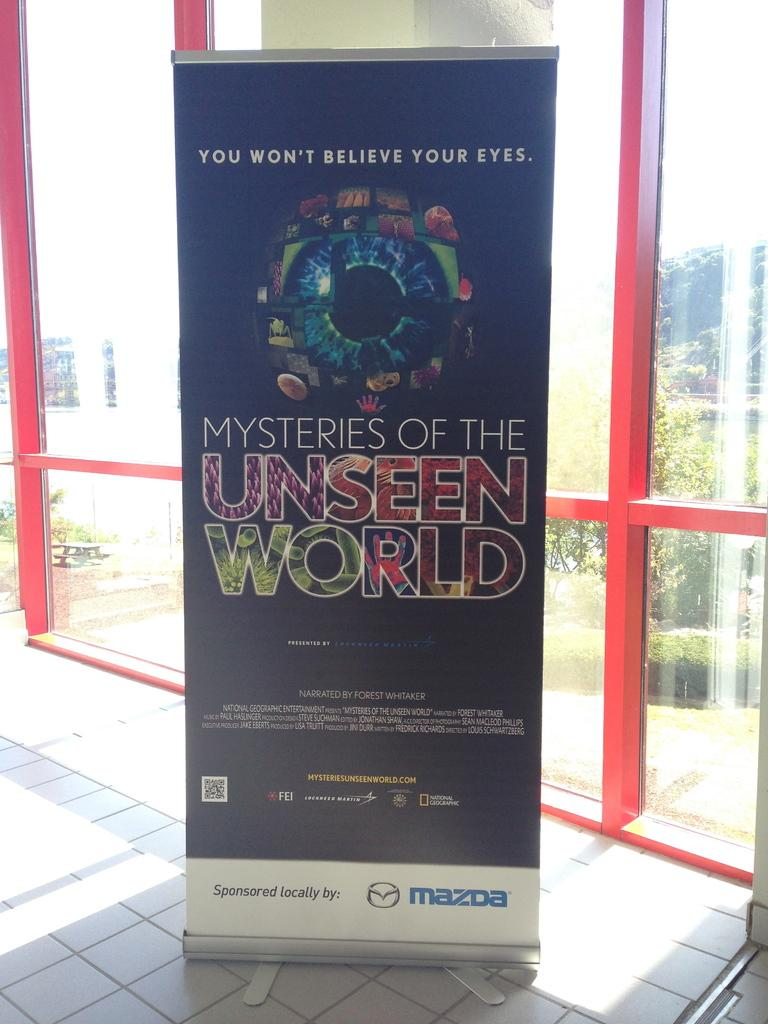<image>
Summarize the visual content of the image. a poster that is advertised for unseen world 